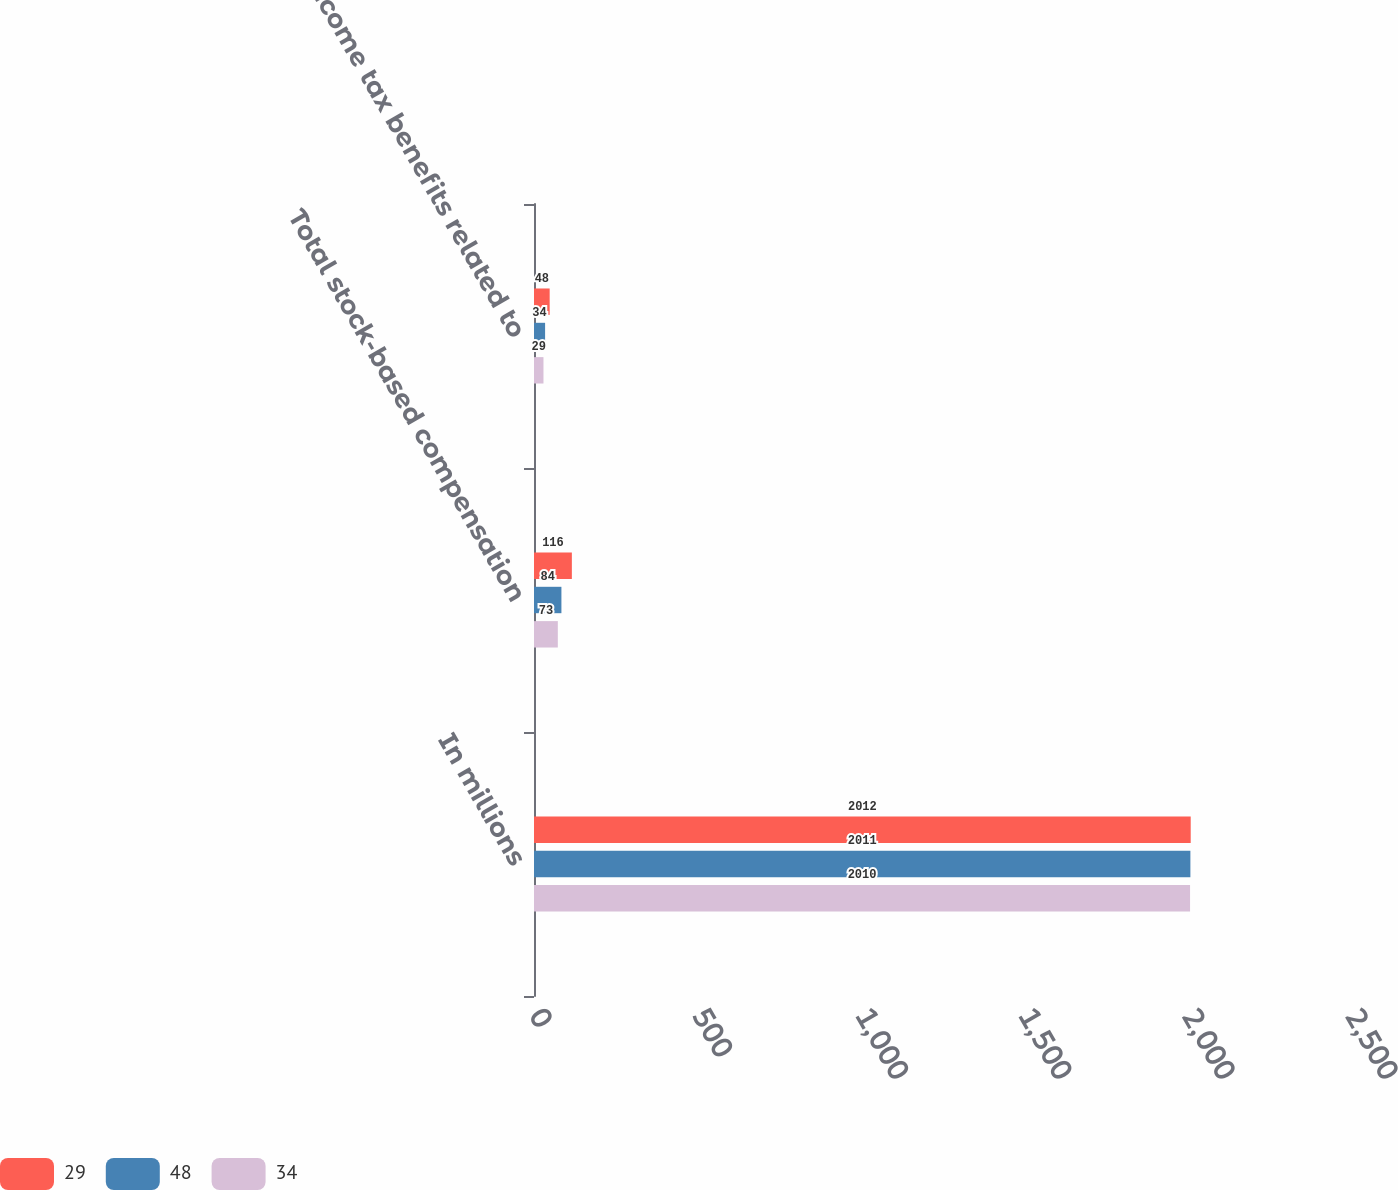<chart> <loc_0><loc_0><loc_500><loc_500><stacked_bar_chart><ecel><fcel>In millions<fcel>Total stock-based compensation<fcel>Income tax benefits related to<nl><fcel>29<fcel>2012<fcel>116<fcel>48<nl><fcel>48<fcel>2011<fcel>84<fcel>34<nl><fcel>34<fcel>2010<fcel>73<fcel>29<nl></chart> 